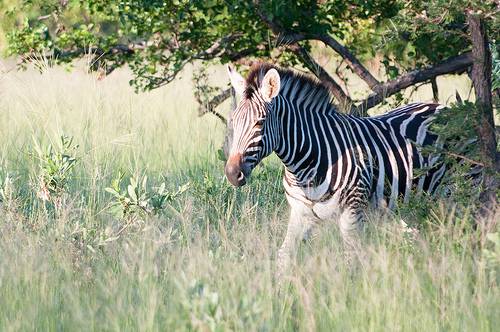Please provide a short description for this region: [0.43, 0.34, 0.78, 0.55]. In the region defined by the coordinates [0.43, 0.34, 0.78, 0.55], you can see part of the zebra's body displaying its characteristic black and white stripes. 